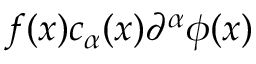Convert formula to latex. <formula><loc_0><loc_0><loc_500><loc_500>f ( x ) c _ { \alpha } ( x ) \partial ^ { \alpha } \phi ( x )</formula> 